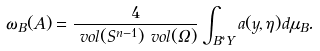Convert formula to latex. <formula><loc_0><loc_0><loc_500><loc_500>\omega _ { B } ( A ) & = \frac { 4 } { \ v o l ( S ^ { n - 1 } ) \ v o l ( \Omega ) } \int _ { B ^ { * } Y } a ( y , \eta ) d \mu _ { B } .</formula> 